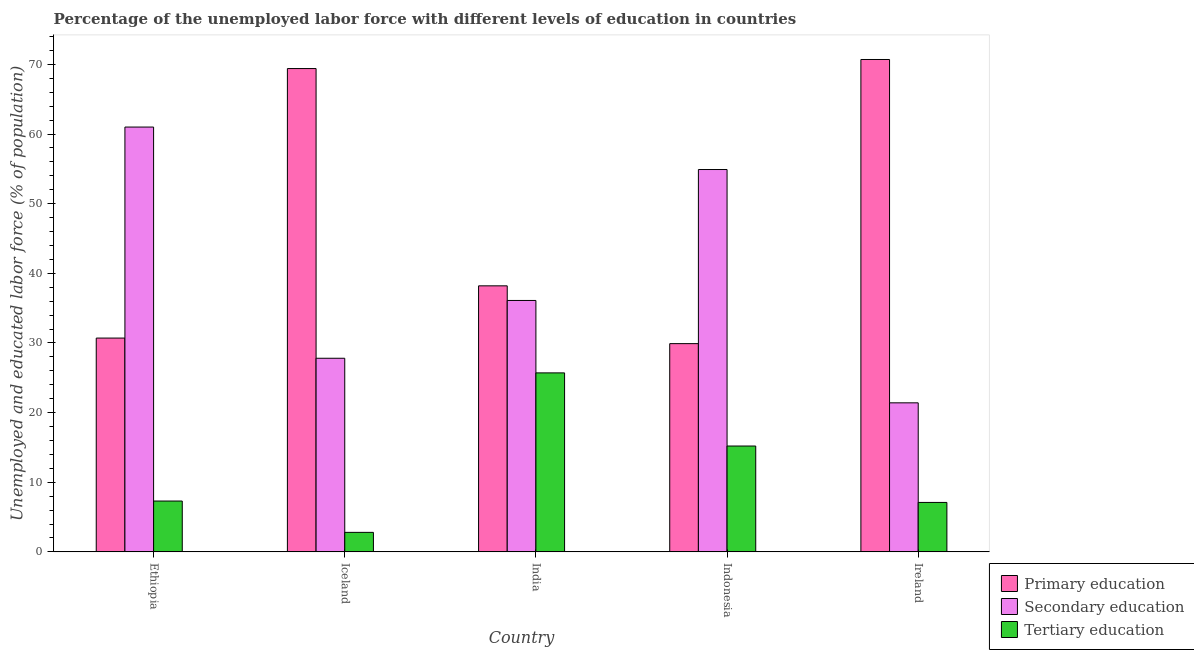How many groups of bars are there?
Your answer should be very brief. 5. How many bars are there on the 5th tick from the right?
Your answer should be very brief. 3. What is the label of the 5th group of bars from the left?
Provide a succinct answer. Ireland. What is the percentage of labor force who received secondary education in Indonesia?
Your answer should be very brief. 54.9. Across all countries, what is the maximum percentage of labor force who received secondary education?
Your response must be concise. 61. Across all countries, what is the minimum percentage of labor force who received secondary education?
Offer a terse response. 21.4. In which country was the percentage of labor force who received primary education maximum?
Offer a very short reply. Ireland. In which country was the percentage of labor force who received secondary education minimum?
Provide a short and direct response. Ireland. What is the total percentage of labor force who received secondary education in the graph?
Make the answer very short. 201.2. What is the difference between the percentage of labor force who received tertiary education in Iceland and that in India?
Provide a short and direct response. -22.9. What is the difference between the percentage of labor force who received primary education in India and the percentage of labor force who received secondary education in Ethiopia?
Keep it short and to the point. -22.8. What is the average percentage of labor force who received primary education per country?
Provide a short and direct response. 47.78. What is the difference between the percentage of labor force who received secondary education and percentage of labor force who received tertiary education in India?
Ensure brevity in your answer.  10.4. What is the ratio of the percentage of labor force who received tertiary education in Iceland to that in India?
Provide a short and direct response. 0.11. What is the difference between the highest and the second highest percentage of labor force who received tertiary education?
Make the answer very short. 10.5. What is the difference between the highest and the lowest percentage of labor force who received secondary education?
Offer a terse response. 39.6. Is the sum of the percentage of labor force who received tertiary education in Iceland and Indonesia greater than the maximum percentage of labor force who received secondary education across all countries?
Ensure brevity in your answer.  No. What does the 2nd bar from the left in Ethiopia represents?
Provide a short and direct response. Secondary education. What does the 3rd bar from the right in Iceland represents?
Offer a very short reply. Primary education. Is it the case that in every country, the sum of the percentage of labor force who received primary education and percentage of labor force who received secondary education is greater than the percentage of labor force who received tertiary education?
Make the answer very short. Yes. What is the difference between two consecutive major ticks on the Y-axis?
Provide a succinct answer. 10. Does the graph contain any zero values?
Your response must be concise. No. Where does the legend appear in the graph?
Your answer should be compact. Bottom right. What is the title of the graph?
Keep it short and to the point. Percentage of the unemployed labor force with different levels of education in countries. What is the label or title of the Y-axis?
Your answer should be compact. Unemployed and educated labor force (% of population). What is the Unemployed and educated labor force (% of population) of Primary education in Ethiopia?
Offer a very short reply. 30.7. What is the Unemployed and educated labor force (% of population) in Tertiary education in Ethiopia?
Provide a short and direct response. 7.3. What is the Unemployed and educated labor force (% of population) in Primary education in Iceland?
Your response must be concise. 69.4. What is the Unemployed and educated labor force (% of population) in Secondary education in Iceland?
Your answer should be compact. 27.8. What is the Unemployed and educated labor force (% of population) in Tertiary education in Iceland?
Provide a short and direct response. 2.8. What is the Unemployed and educated labor force (% of population) of Primary education in India?
Your answer should be compact. 38.2. What is the Unemployed and educated labor force (% of population) of Secondary education in India?
Give a very brief answer. 36.1. What is the Unemployed and educated labor force (% of population) of Tertiary education in India?
Keep it short and to the point. 25.7. What is the Unemployed and educated labor force (% of population) in Primary education in Indonesia?
Provide a succinct answer. 29.9. What is the Unemployed and educated labor force (% of population) of Secondary education in Indonesia?
Provide a succinct answer. 54.9. What is the Unemployed and educated labor force (% of population) in Tertiary education in Indonesia?
Provide a succinct answer. 15.2. What is the Unemployed and educated labor force (% of population) in Primary education in Ireland?
Offer a very short reply. 70.7. What is the Unemployed and educated labor force (% of population) of Secondary education in Ireland?
Offer a terse response. 21.4. What is the Unemployed and educated labor force (% of population) of Tertiary education in Ireland?
Provide a succinct answer. 7.1. Across all countries, what is the maximum Unemployed and educated labor force (% of population) of Primary education?
Ensure brevity in your answer.  70.7. Across all countries, what is the maximum Unemployed and educated labor force (% of population) in Tertiary education?
Make the answer very short. 25.7. Across all countries, what is the minimum Unemployed and educated labor force (% of population) of Primary education?
Offer a terse response. 29.9. Across all countries, what is the minimum Unemployed and educated labor force (% of population) of Secondary education?
Make the answer very short. 21.4. Across all countries, what is the minimum Unemployed and educated labor force (% of population) of Tertiary education?
Make the answer very short. 2.8. What is the total Unemployed and educated labor force (% of population) of Primary education in the graph?
Your answer should be compact. 238.9. What is the total Unemployed and educated labor force (% of population) in Secondary education in the graph?
Make the answer very short. 201.2. What is the total Unemployed and educated labor force (% of population) in Tertiary education in the graph?
Provide a short and direct response. 58.1. What is the difference between the Unemployed and educated labor force (% of population) in Primary education in Ethiopia and that in Iceland?
Ensure brevity in your answer.  -38.7. What is the difference between the Unemployed and educated labor force (% of population) of Secondary education in Ethiopia and that in Iceland?
Provide a succinct answer. 33.2. What is the difference between the Unemployed and educated labor force (% of population) of Tertiary education in Ethiopia and that in Iceland?
Provide a short and direct response. 4.5. What is the difference between the Unemployed and educated labor force (% of population) of Secondary education in Ethiopia and that in India?
Your answer should be very brief. 24.9. What is the difference between the Unemployed and educated labor force (% of population) in Tertiary education in Ethiopia and that in India?
Your response must be concise. -18.4. What is the difference between the Unemployed and educated labor force (% of population) in Primary education in Ethiopia and that in Indonesia?
Make the answer very short. 0.8. What is the difference between the Unemployed and educated labor force (% of population) in Secondary education in Ethiopia and that in Indonesia?
Keep it short and to the point. 6.1. What is the difference between the Unemployed and educated labor force (% of population) of Secondary education in Ethiopia and that in Ireland?
Give a very brief answer. 39.6. What is the difference between the Unemployed and educated labor force (% of population) of Primary education in Iceland and that in India?
Offer a very short reply. 31.2. What is the difference between the Unemployed and educated labor force (% of population) in Secondary education in Iceland and that in India?
Your response must be concise. -8.3. What is the difference between the Unemployed and educated labor force (% of population) in Tertiary education in Iceland and that in India?
Give a very brief answer. -22.9. What is the difference between the Unemployed and educated labor force (% of population) of Primary education in Iceland and that in Indonesia?
Your answer should be compact. 39.5. What is the difference between the Unemployed and educated labor force (% of population) in Secondary education in Iceland and that in Indonesia?
Ensure brevity in your answer.  -27.1. What is the difference between the Unemployed and educated labor force (% of population) in Primary education in Iceland and that in Ireland?
Your response must be concise. -1.3. What is the difference between the Unemployed and educated labor force (% of population) of Secondary education in Iceland and that in Ireland?
Your answer should be very brief. 6.4. What is the difference between the Unemployed and educated labor force (% of population) in Primary education in India and that in Indonesia?
Make the answer very short. 8.3. What is the difference between the Unemployed and educated labor force (% of population) of Secondary education in India and that in Indonesia?
Ensure brevity in your answer.  -18.8. What is the difference between the Unemployed and educated labor force (% of population) in Tertiary education in India and that in Indonesia?
Ensure brevity in your answer.  10.5. What is the difference between the Unemployed and educated labor force (% of population) of Primary education in India and that in Ireland?
Your response must be concise. -32.5. What is the difference between the Unemployed and educated labor force (% of population) of Tertiary education in India and that in Ireland?
Offer a terse response. 18.6. What is the difference between the Unemployed and educated labor force (% of population) in Primary education in Indonesia and that in Ireland?
Your answer should be compact. -40.8. What is the difference between the Unemployed and educated labor force (% of population) of Secondary education in Indonesia and that in Ireland?
Keep it short and to the point. 33.5. What is the difference between the Unemployed and educated labor force (% of population) of Primary education in Ethiopia and the Unemployed and educated labor force (% of population) of Secondary education in Iceland?
Give a very brief answer. 2.9. What is the difference between the Unemployed and educated labor force (% of population) of Primary education in Ethiopia and the Unemployed and educated labor force (% of population) of Tertiary education in Iceland?
Ensure brevity in your answer.  27.9. What is the difference between the Unemployed and educated labor force (% of population) in Secondary education in Ethiopia and the Unemployed and educated labor force (% of population) in Tertiary education in Iceland?
Your response must be concise. 58.2. What is the difference between the Unemployed and educated labor force (% of population) of Secondary education in Ethiopia and the Unemployed and educated labor force (% of population) of Tertiary education in India?
Make the answer very short. 35.3. What is the difference between the Unemployed and educated labor force (% of population) in Primary education in Ethiopia and the Unemployed and educated labor force (% of population) in Secondary education in Indonesia?
Give a very brief answer. -24.2. What is the difference between the Unemployed and educated labor force (% of population) in Secondary education in Ethiopia and the Unemployed and educated labor force (% of population) in Tertiary education in Indonesia?
Offer a very short reply. 45.8. What is the difference between the Unemployed and educated labor force (% of population) in Primary education in Ethiopia and the Unemployed and educated labor force (% of population) in Secondary education in Ireland?
Make the answer very short. 9.3. What is the difference between the Unemployed and educated labor force (% of population) in Primary education in Ethiopia and the Unemployed and educated labor force (% of population) in Tertiary education in Ireland?
Your answer should be compact. 23.6. What is the difference between the Unemployed and educated labor force (% of population) in Secondary education in Ethiopia and the Unemployed and educated labor force (% of population) in Tertiary education in Ireland?
Keep it short and to the point. 53.9. What is the difference between the Unemployed and educated labor force (% of population) of Primary education in Iceland and the Unemployed and educated labor force (% of population) of Secondary education in India?
Give a very brief answer. 33.3. What is the difference between the Unemployed and educated labor force (% of population) in Primary education in Iceland and the Unemployed and educated labor force (% of population) in Tertiary education in India?
Your response must be concise. 43.7. What is the difference between the Unemployed and educated labor force (% of population) in Secondary education in Iceland and the Unemployed and educated labor force (% of population) in Tertiary education in India?
Give a very brief answer. 2.1. What is the difference between the Unemployed and educated labor force (% of population) in Primary education in Iceland and the Unemployed and educated labor force (% of population) in Tertiary education in Indonesia?
Offer a very short reply. 54.2. What is the difference between the Unemployed and educated labor force (% of population) of Secondary education in Iceland and the Unemployed and educated labor force (% of population) of Tertiary education in Indonesia?
Give a very brief answer. 12.6. What is the difference between the Unemployed and educated labor force (% of population) in Primary education in Iceland and the Unemployed and educated labor force (% of population) in Tertiary education in Ireland?
Your response must be concise. 62.3. What is the difference between the Unemployed and educated labor force (% of population) of Secondary education in Iceland and the Unemployed and educated labor force (% of population) of Tertiary education in Ireland?
Your answer should be very brief. 20.7. What is the difference between the Unemployed and educated labor force (% of population) of Primary education in India and the Unemployed and educated labor force (% of population) of Secondary education in Indonesia?
Your answer should be compact. -16.7. What is the difference between the Unemployed and educated labor force (% of population) in Primary education in India and the Unemployed and educated labor force (% of population) in Tertiary education in Indonesia?
Provide a succinct answer. 23. What is the difference between the Unemployed and educated labor force (% of population) of Secondary education in India and the Unemployed and educated labor force (% of population) of Tertiary education in Indonesia?
Offer a very short reply. 20.9. What is the difference between the Unemployed and educated labor force (% of population) of Primary education in India and the Unemployed and educated labor force (% of population) of Tertiary education in Ireland?
Give a very brief answer. 31.1. What is the difference between the Unemployed and educated labor force (% of population) in Primary education in Indonesia and the Unemployed and educated labor force (% of population) in Tertiary education in Ireland?
Offer a very short reply. 22.8. What is the difference between the Unemployed and educated labor force (% of population) of Secondary education in Indonesia and the Unemployed and educated labor force (% of population) of Tertiary education in Ireland?
Make the answer very short. 47.8. What is the average Unemployed and educated labor force (% of population) in Primary education per country?
Make the answer very short. 47.78. What is the average Unemployed and educated labor force (% of population) in Secondary education per country?
Keep it short and to the point. 40.24. What is the average Unemployed and educated labor force (% of population) of Tertiary education per country?
Your answer should be compact. 11.62. What is the difference between the Unemployed and educated labor force (% of population) of Primary education and Unemployed and educated labor force (% of population) of Secondary education in Ethiopia?
Your response must be concise. -30.3. What is the difference between the Unemployed and educated labor force (% of population) in Primary education and Unemployed and educated labor force (% of population) in Tertiary education in Ethiopia?
Keep it short and to the point. 23.4. What is the difference between the Unemployed and educated labor force (% of population) in Secondary education and Unemployed and educated labor force (% of population) in Tertiary education in Ethiopia?
Provide a succinct answer. 53.7. What is the difference between the Unemployed and educated labor force (% of population) of Primary education and Unemployed and educated labor force (% of population) of Secondary education in Iceland?
Provide a succinct answer. 41.6. What is the difference between the Unemployed and educated labor force (% of population) in Primary education and Unemployed and educated labor force (% of population) in Tertiary education in Iceland?
Provide a short and direct response. 66.6. What is the difference between the Unemployed and educated labor force (% of population) of Primary education and Unemployed and educated labor force (% of population) of Secondary education in India?
Ensure brevity in your answer.  2.1. What is the difference between the Unemployed and educated labor force (% of population) of Secondary education and Unemployed and educated labor force (% of population) of Tertiary education in Indonesia?
Ensure brevity in your answer.  39.7. What is the difference between the Unemployed and educated labor force (% of population) of Primary education and Unemployed and educated labor force (% of population) of Secondary education in Ireland?
Offer a very short reply. 49.3. What is the difference between the Unemployed and educated labor force (% of population) of Primary education and Unemployed and educated labor force (% of population) of Tertiary education in Ireland?
Provide a succinct answer. 63.6. What is the difference between the Unemployed and educated labor force (% of population) of Secondary education and Unemployed and educated labor force (% of population) of Tertiary education in Ireland?
Keep it short and to the point. 14.3. What is the ratio of the Unemployed and educated labor force (% of population) of Primary education in Ethiopia to that in Iceland?
Provide a short and direct response. 0.44. What is the ratio of the Unemployed and educated labor force (% of population) in Secondary education in Ethiopia to that in Iceland?
Provide a short and direct response. 2.19. What is the ratio of the Unemployed and educated labor force (% of population) of Tertiary education in Ethiopia to that in Iceland?
Your response must be concise. 2.61. What is the ratio of the Unemployed and educated labor force (% of population) in Primary education in Ethiopia to that in India?
Your response must be concise. 0.8. What is the ratio of the Unemployed and educated labor force (% of population) of Secondary education in Ethiopia to that in India?
Your answer should be very brief. 1.69. What is the ratio of the Unemployed and educated labor force (% of population) of Tertiary education in Ethiopia to that in India?
Offer a very short reply. 0.28. What is the ratio of the Unemployed and educated labor force (% of population) of Primary education in Ethiopia to that in Indonesia?
Your answer should be very brief. 1.03. What is the ratio of the Unemployed and educated labor force (% of population) in Secondary education in Ethiopia to that in Indonesia?
Keep it short and to the point. 1.11. What is the ratio of the Unemployed and educated labor force (% of population) of Tertiary education in Ethiopia to that in Indonesia?
Make the answer very short. 0.48. What is the ratio of the Unemployed and educated labor force (% of population) of Primary education in Ethiopia to that in Ireland?
Your answer should be compact. 0.43. What is the ratio of the Unemployed and educated labor force (% of population) in Secondary education in Ethiopia to that in Ireland?
Provide a short and direct response. 2.85. What is the ratio of the Unemployed and educated labor force (% of population) in Tertiary education in Ethiopia to that in Ireland?
Your answer should be compact. 1.03. What is the ratio of the Unemployed and educated labor force (% of population) of Primary education in Iceland to that in India?
Offer a very short reply. 1.82. What is the ratio of the Unemployed and educated labor force (% of population) in Secondary education in Iceland to that in India?
Offer a terse response. 0.77. What is the ratio of the Unemployed and educated labor force (% of population) in Tertiary education in Iceland to that in India?
Offer a terse response. 0.11. What is the ratio of the Unemployed and educated labor force (% of population) of Primary education in Iceland to that in Indonesia?
Offer a terse response. 2.32. What is the ratio of the Unemployed and educated labor force (% of population) of Secondary education in Iceland to that in Indonesia?
Ensure brevity in your answer.  0.51. What is the ratio of the Unemployed and educated labor force (% of population) in Tertiary education in Iceland to that in Indonesia?
Keep it short and to the point. 0.18. What is the ratio of the Unemployed and educated labor force (% of population) in Primary education in Iceland to that in Ireland?
Give a very brief answer. 0.98. What is the ratio of the Unemployed and educated labor force (% of population) of Secondary education in Iceland to that in Ireland?
Your answer should be compact. 1.3. What is the ratio of the Unemployed and educated labor force (% of population) in Tertiary education in Iceland to that in Ireland?
Keep it short and to the point. 0.39. What is the ratio of the Unemployed and educated labor force (% of population) of Primary education in India to that in Indonesia?
Make the answer very short. 1.28. What is the ratio of the Unemployed and educated labor force (% of population) in Secondary education in India to that in Indonesia?
Offer a very short reply. 0.66. What is the ratio of the Unemployed and educated labor force (% of population) of Tertiary education in India to that in Indonesia?
Your answer should be compact. 1.69. What is the ratio of the Unemployed and educated labor force (% of population) of Primary education in India to that in Ireland?
Keep it short and to the point. 0.54. What is the ratio of the Unemployed and educated labor force (% of population) in Secondary education in India to that in Ireland?
Make the answer very short. 1.69. What is the ratio of the Unemployed and educated labor force (% of population) in Tertiary education in India to that in Ireland?
Your answer should be compact. 3.62. What is the ratio of the Unemployed and educated labor force (% of population) in Primary education in Indonesia to that in Ireland?
Your answer should be compact. 0.42. What is the ratio of the Unemployed and educated labor force (% of population) of Secondary education in Indonesia to that in Ireland?
Offer a terse response. 2.57. What is the ratio of the Unemployed and educated labor force (% of population) of Tertiary education in Indonesia to that in Ireland?
Provide a succinct answer. 2.14. What is the difference between the highest and the second highest Unemployed and educated labor force (% of population) of Secondary education?
Offer a terse response. 6.1. What is the difference between the highest and the second highest Unemployed and educated labor force (% of population) in Tertiary education?
Provide a succinct answer. 10.5. What is the difference between the highest and the lowest Unemployed and educated labor force (% of population) of Primary education?
Keep it short and to the point. 40.8. What is the difference between the highest and the lowest Unemployed and educated labor force (% of population) of Secondary education?
Offer a terse response. 39.6. What is the difference between the highest and the lowest Unemployed and educated labor force (% of population) of Tertiary education?
Offer a terse response. 22.9. 